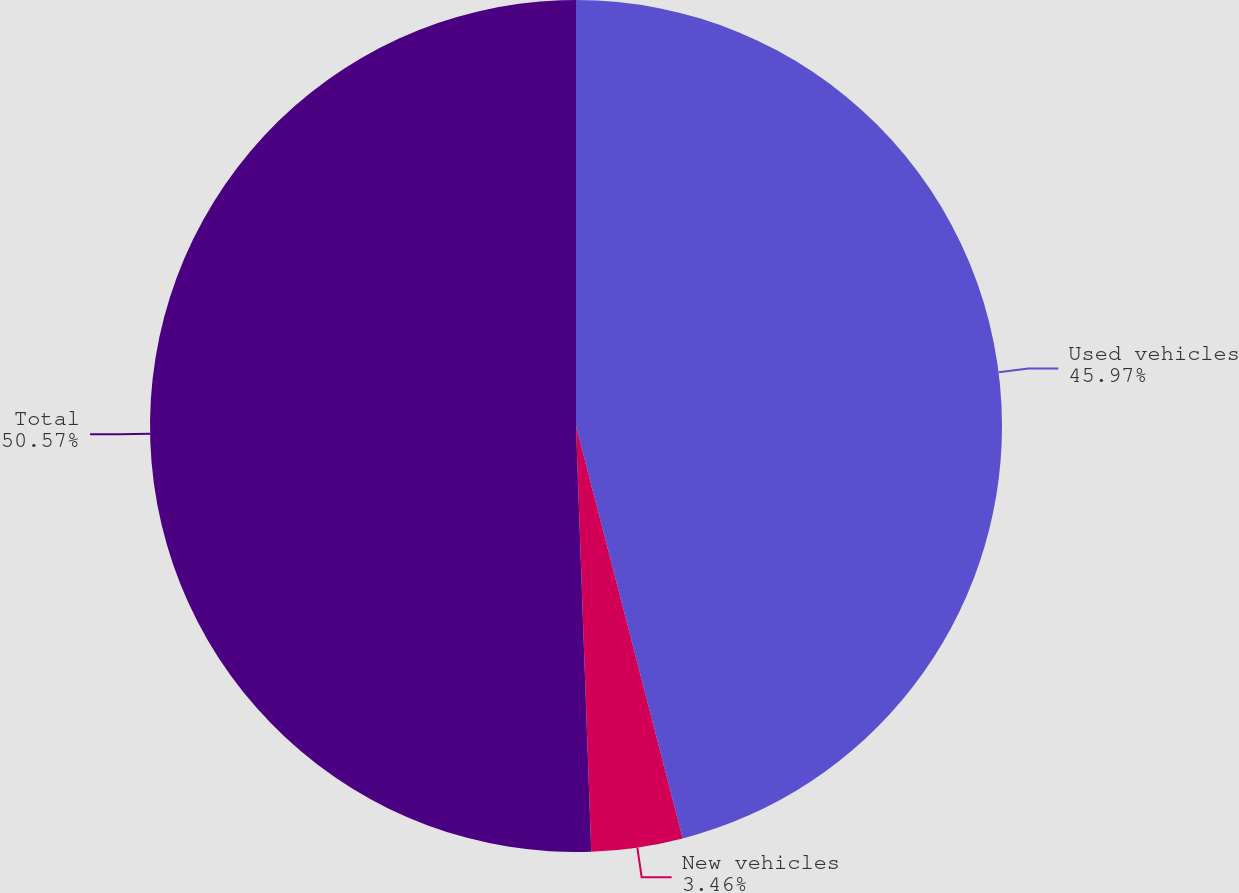Convert chart. <chart><loc_0><loc_0><loc_500><loc_500><pie_chart><fcel>Used vehicles<fcel>New vehicles<fcel>Total<nl><fcel>45.97%<fcel>3.46%<fcel>50.57%<nl></chart> 